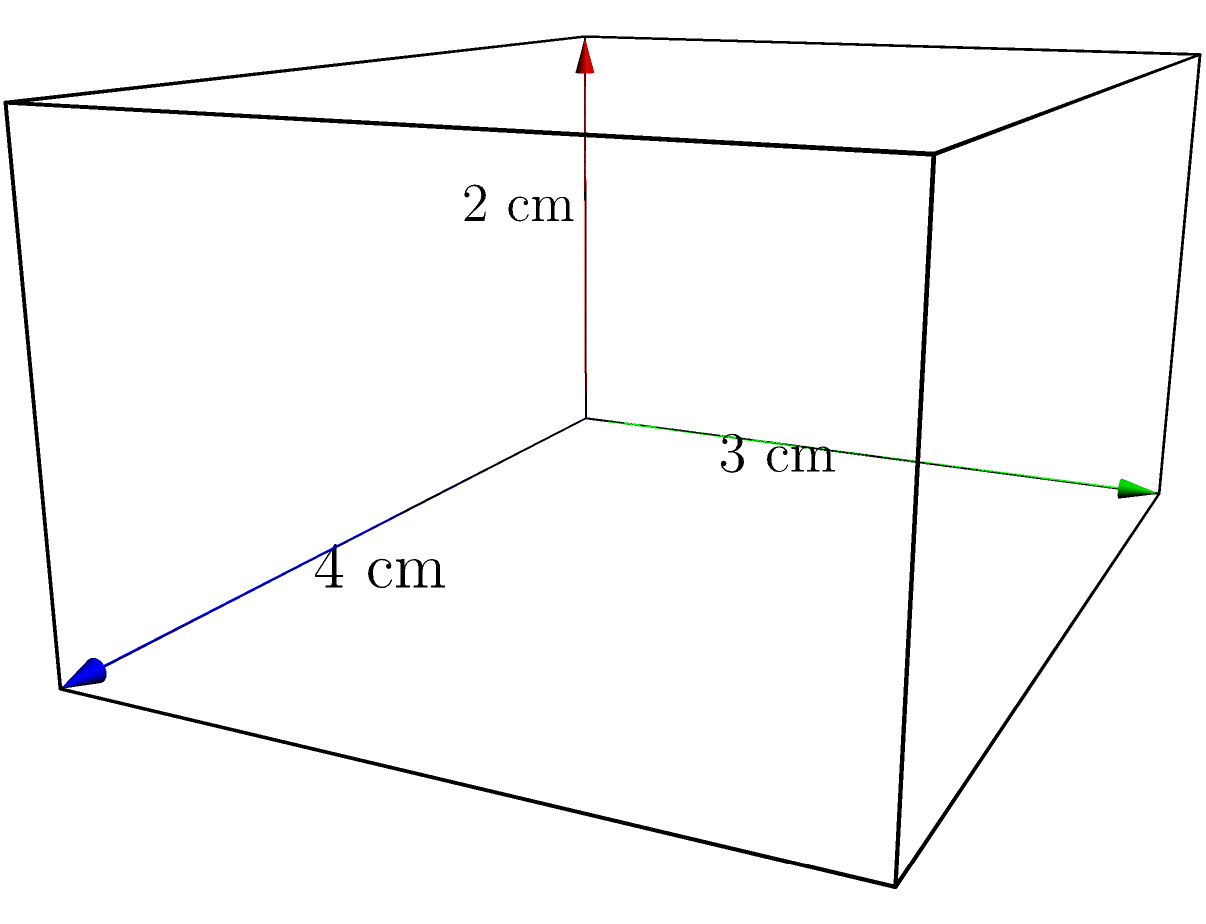As a literary agent, you're reviewing a manuscript for a persuasive writing textbook that includes a geometry section. One problem involves calculating the surface area of a rectangular prism. Given the dimensions shown in the diagram (length = 4 cm, width = 3 cm, height = 2 cm), what is the total surface area of the prism? Express your answer in square centimeters (cm²). To find the surface area of a rectangular prism, we need to calculate the area of each face and sum them up. Let's break it down step-by-step:

1. Identify the dimensions:
   Length (l) = 4 cm
   Width (w) = 3 cm
   Height (h) = 2 cm

2. Calculate the areas of each pair of faces:
   a. Front and back faces: $l * h = 4 * 2 = 8$ cm²
      Total area: $8 * 2 = 16$ cm²
   
   b. Top and bottom faces: $l * w = 4 * 3 = 12$ cm²
      Total area: $12 * 2 = 24$ cm²
   
   c. Left and right faces: $w * h = 3 * 2 = 6$ cm²
      Total area: $6 * 2 = 12$ cm²

3. Sum up all the face areas:
   Total surface area = Front/back + Top/bottom + Left/right
   $$ 16 + 24 + 12 = 52 \text{ cm²} $$

Therefore, the total surface area of the rectangular prism is 52 cm².
Answer: 52 cm² 